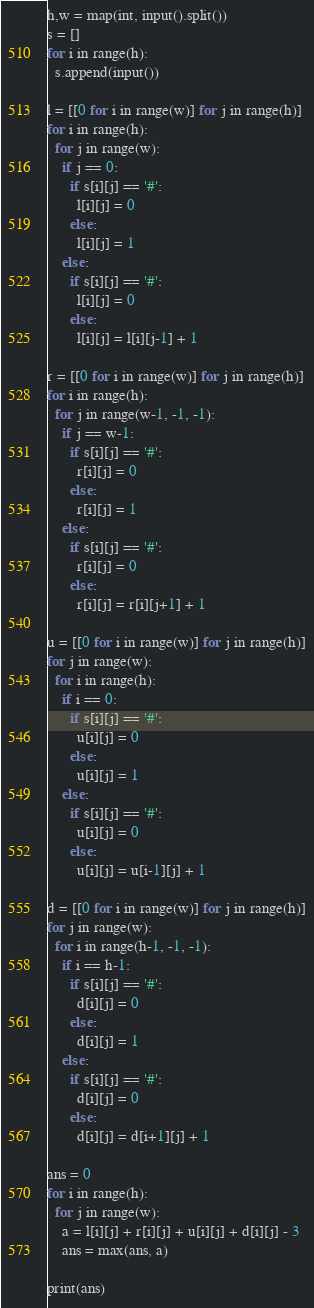Convert code to text. <code><loc_0><loc_0><loc_500><loc_500><_Python_>h,w = map(int, input().split())
s = []
for i in range(h):
  s.append(input())

l = [[0 for i in range(w)] for j in range(h)]
for i in range(h):
  for j in range(w):
    if j == 0:
      if s[i][j] == '#':
        l[i][j] = 0
      else:
        l[i][j] = 1
    else:
      if s[i][j] == '#':
        l[i][j] = 0
      else:
        l[i][j] = l[i][j-1] + 1

r = [[0 for i in range(w)] for j in range(h)]
for i in range(h):
  for j in range(w-1, -1, -1):
    if j == w-1:
      if s[i][j] == '#':
        r[i][j] = 0
      else:
        r[i][j] = 1
    else:
      if s[i][j] == '#':
        r[i][j] = 0
      else:
        r[i][j] = r[i][j+1] + 1

u = [[0 for i in range(w)] for j in range(h)]
for j in range(w):
  for i in range(h):
    if i == 0:
      if s[i][j] == '#':
        u[i][j] = 0
      else:
        u[i][j] = 1
    else:
      if s[i][j] == '#':
        u[i][j] = 0
      else:
        u[i][j] = u[i-1][j] + 1

d = [[0 for i in range(w)] for j in range(h)]
for j in range(w):
  for i in range(h-1, -1, -1):
    if i == h-1:
      if s[i][j] == '#':
        d[i][j] = 0
      else:
        d[i][j] = 1
    else:
      if s[i][j] == '#':
        d[i][j] = 0
      else:
        d[i][j] = d[i+1][j] + 1

ans = 0
for i in range(h):
  for j in range(w):
    a = l[i][j] + r[i][j] + u[i][j] + d[i][j] - 3
    ans = max(ans, a)

print(ans)</code> 